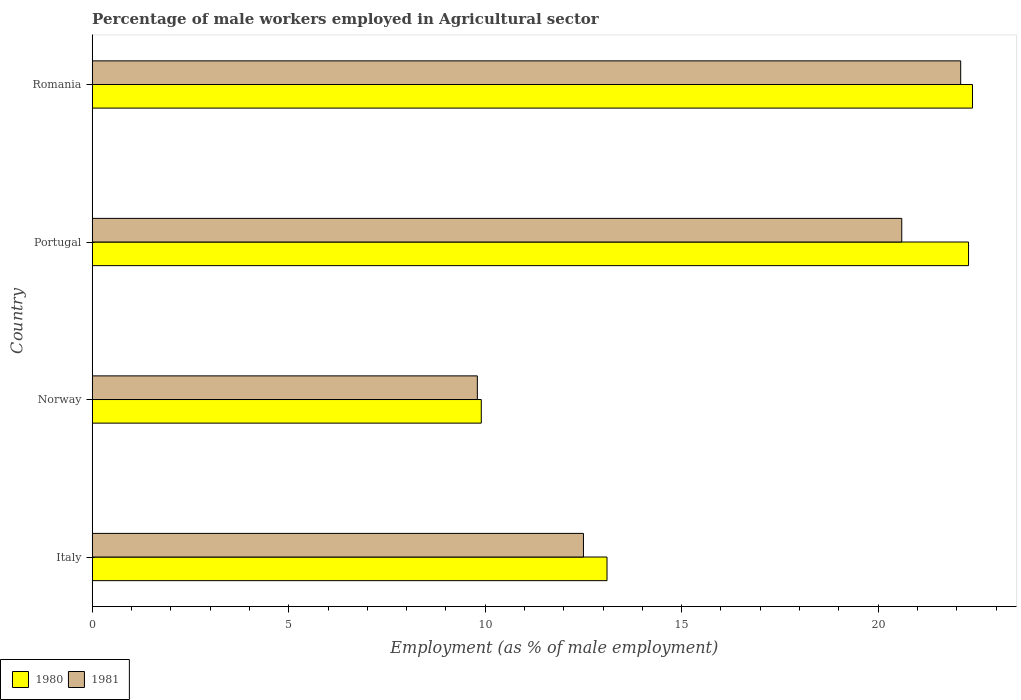Are the number of bars per tick equal to the number of legend labels?
Give a very brief answer. Yes. Are the number of bars on each tick of the Y-axis equal?
Offer a very short reply. Yes. What is the label of the 2nd group of bars from the top?
Make the answer very short. Portugal. In how many cases, is the number of bars for a given country not equal to the number of legend labels?
Ensure brevity in your answer.  0. What is the percentage of male workers employed in Agricultural sector in 1981 in Portugal?
Give a very brief answer. 20.6. Across all countries, what is the maximum percentage of male workers employed in Agricultural sector in 1980?
Keep it short and to the point. 22.4. Across all countries, what is the minimum percentage of male workers employed in Agricultural sector in 1981?
Your response must be concise. 9.8. In which country was the percentage of male workers employed in Agricultural sector in 1981 maximum?
Provide a short and direct response. Romania. In which country was the percentage of male workers employed in Agricultural sector in 1981 minimum?
Provide a short and direct response. Norway. What is the total percentage of male workers employed in Agricultural sector in 1980 in the graph?
Ensure brevity in your answer.  67.7. What is the difference between the percentage of male workers employed in Agricultural sector in 1980 in Italy and that in Norway?
Your answer should be compact. 3.2. What is the difference between the percentage of male workers employed in Agricultural sector in 1980 in Italy and the percentage of male workers employed in Agricultural sector in 1981 in Romania?
Make the answer very short. -9. What is the average percentage of male workers employed in Agricultural sector in 1980 per country?
Offer a terse response. 16.92. What is the difference between the percentage of male workers employed in Agricultural sector in 1980 and percentage of male workers employed in Agricultural sector in 1981 in Italy?
Offer a very short reply. 0.6. What is the ratio of the percentage of male workers employed in Agricultural sector in 1981 in Norway to that in Romania?
Your response must be concise. 0.44. What is the difference between the highest and the second highest percentage of male workers employed in Agricultural sector in 1981?
Offer a terse response. 1.5. What is the difference between the highest and the lowest percentage of male workers employed in Agricultural sector in 1981?
Provide a succinct answer. 12.3. In how many countries, is the percentage of male workers employed in Agricultural sector in 1980 greater than the average percentage of male workers employed in Agricultural sector in 1980 taken over all countries?
Offer a terse response. 2. How many bars are there?
Offer a terse response. 8. How many countries are there in the graph?
Make the answer very short. 4. What is the difference between two consecutive major ticks on the X-axis?
Make the answer very short. 5. Does the graph contain any zero values?
Provide a succinct answer. No. Does the graph contain grids?
Offer a terse response. No. How many legend labels are there?
Your answer should be compact. 2. What is the title of the graph?
Your answer should be compact. Percentage of male workers employed in Agricultural sector. Does "1976" appear as one of the legend labels in the graph?
Provide a short and direct response. No. What is the label or title of the X-axis?
Ensure brevity in your answer.  Employment (as % of male employment). What is the Employment (as % of male employment) in 1980 in Italy?
Your answer should be compact. 13.1. What is the Employment (as % of male employment) in 1981 in Italy?
Your answer should be very brief. 12.5. What is the Employment (as % of male employment) of 1980 in Norway?
Make the answer very short. 9.9. What is the Employment (as % of male employment) of 1981 in Norway?
Offer a terse response. 9.8. What is the Employment (as % of male employment) in 1980 in Portugal?
Your answer should be compact. 22.3. What is the Employment (as % of male employment) in 1981 in Portugal?
Your response must be concise. 20.6. What is the Employment (as % of male employment) in 1980 in Romania?
Offer a very short reply. 22.4. What is the Employment (as % of male employment) in 1981 in Romania?
Provide a short and direct response. 22.1. Across all countries, what is the maximum Employment (as % of male employment) in 1980?
Provide a short and direct response. 22.4. Across all countries, what is the maximum Employment (as % of male employment) of 1981?
Ensure brevity in your answer.  22.1. Across all countries, what is the minimum Employment (as % of male employment) of 1980?
Provide a succinct answer. 9.9. Across all countries, what is the minimum Employment (as % of male employment) of 1981?
Your answer should be compact. 9.8. What is the total Employment (as % of male employment) in 1980 in the graph?
Your answer should be very brief. 67.7. What is the difference between the Employment (as % of male employment) in 1980 in Italy and that in Norway?
Keep it short and to the point. 3.2. What is the difference between the Employment (as % of male employment) in 1980 in Italy and that in Romania?
Your response must be concise. -9.3. What is the difference between the Employment (as % of male employment) of 1981 in Italy and that in Romania?
Keep it short and to the point. -9.6. What is the difference between the Employment (as % of male employment) of 1980 in Norway and that in Portugal?
Ensure brevity in your answer.  -12.4. What is the difference between the Employment (as % of male employment) of 1981 in Norway and that in Portugal?
Make the answer very short. -10.8. What is the difference between the Employment (as % of male employment) in 1981 in Norway and that in Romania?
Your response must be concise. -12.3. What is the difference between the Employment (as % of male employment) of 1980 in Italy and the Employment (as % of male employment) of 1981 in Portugal?
Make the answer very short. -7.5. What is the average Employment (as % of male employment) of 1980 per country?
Keep it short and to the point. 16.93. What is the average Employment (as % of male employment) in 1981 per country?
Your response must be concise. 16.25. What is the difference between the Employment (as % of male employment) in 1980 and Employment (as % of male employment) in 1981 in Norway?
Give a very brief answer. 0.1. What is the ratio of the Employment (as % of male employment) in 1980 in Italy to that in Norway?
Give a very brief answer. 1.32. What is the ratio of the Employment (as % of male employment) of 1981 in Italy to that in Norway?
Ensure brevity in your answer.  1.28. What is the ratio of the Employment (as % of male employment) in 1980 in Italy to that in Portugal?
Offer a terse response. 0.59. What is the ratio of the Employment (as % of male employment) in 1981 in Italy to that in Portugal?
Offer a terse response. 0.61. What is the ratio of the Employment (as % of male employment) of 1980 in Italy to that in Romania?
Provide a short and direct response. 0.58. What is the ratio of the Employment (as % of male employment) of 1981 in Italy to that in Romania?
Your answer should be very brief. 0.57. What is the ratio of the Employment (as % of male employment) in 1980 in Norway to that in Portugal?
Offer a terse response. 0.44. What is the ratio of the Employment (as % of male employment) of 1981 in Norway to that in Portugal?
Give a very brief answer. 0.48. What is the ratio of the Employment (as % of male employment) in 1980 in Norway to that in Romania?
Keep it short and to the point. 0.44. What is the ratio of the Employment (as % of male employment) of 1981 in Norway to that in Romania?
Your response must be concise. 0.44. What is the ratio of the Employment (as % of male employment) of 1980 in Portugal to that in Romania?
Your answer should be very brief. 1. What is the ratio of the Employment (as % of male employment) in 1981 in Portugal to that in Romania?
Ensure brevity in your answer.  0.93. What is the difference between the highest and the lowest Employment (as % of male employment) in 1980?
Your answer should be very brief. 12.5. 